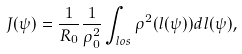Convert formula to latex. <formula><loc_0><loc_0><loc_500><loc_500>J ( \psi ) = \frac { 1 } { R _ { 0 } } \frac { 1 } { \rho _ { 0 } ^ { 2 } } \int _ { l o s } \rho ^ { 2 } ( l ( \psi ) ) d l ( \psi ) ,</formula> 